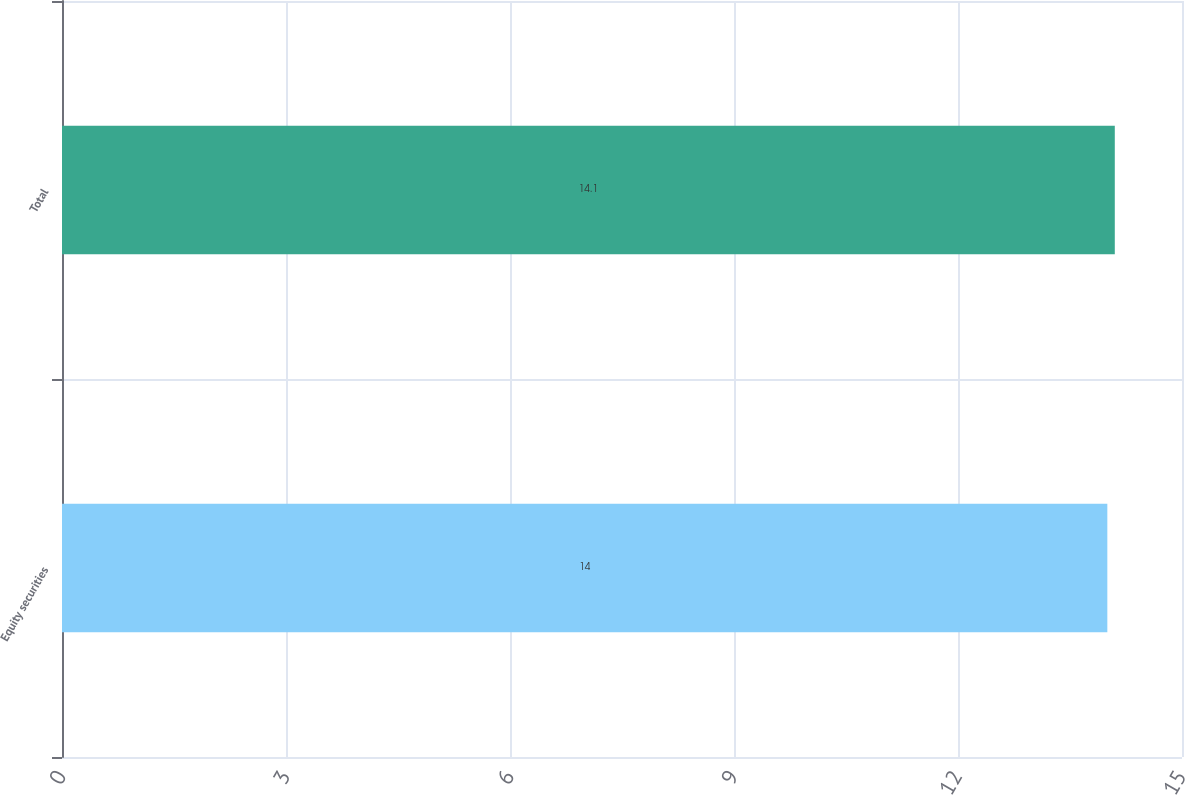Convert chart. <chart><loc_0><loc_0><loc_500><loc_500><bar_chart><fcel>Equity securities<fcel>Total<nl><fcel>14<fcel>14.1<nl></chart> 